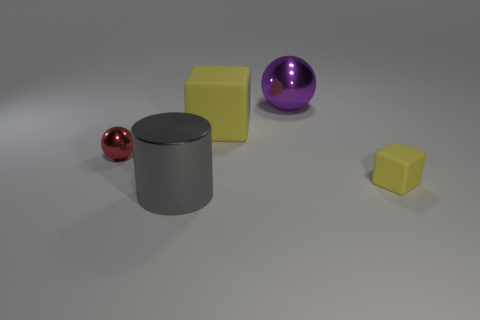Add 3 tiny matte objects. How many objects exist? 8 Subtract all red spheres. How many spheres are left? 1 Subtract all large matte cylinders. Subtract all large rubber cubes. How many objects are left? 4 Add 2 tiny red metallic things. How many tiny red metallic things are left? 3 Add 2 tiny red things. How many tiny red things exist? 3 Subtract 0 green cubes. How many objects are left? 5 Subtract all balls. How many objects are left? 3 Subtract 2 blocks. How many blocks are left? 0 Subtract all blue blocks. Subtract all gray spheres. How many blocks are left? 2 Subtract all yellow cylinders. How many yellow spheres are left? 0 